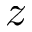Convert formula to latex. <formula><loc_0><loc_0><loc_500><loc_500>z</formula> 